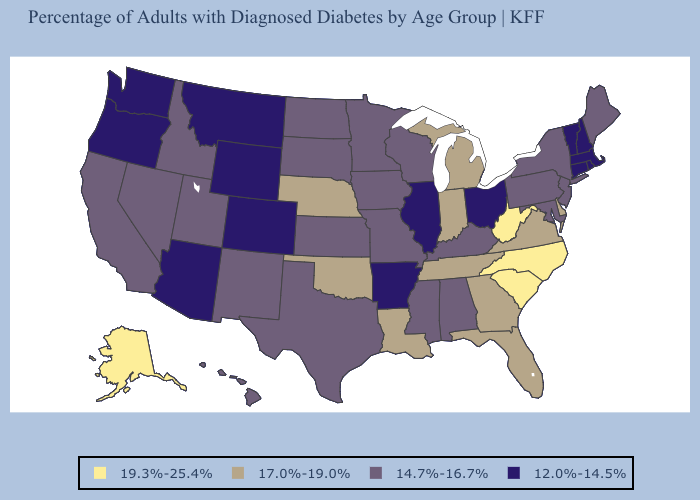Name the states that have a value in the range 17.0%-19.0%?
Quick response, please. Delaware, Florida, Georgia, Indiana, Louisiana, Michigan, Nebraska, Oklahoma, Tennessee, Virginia. What is the lowest value in the Northeast?
Keep it brief. 12.0%-14.5%. What is the value of Delaware?
Quick response, please. 17.0%-19.0%. Name the states that have a value in the range 19.3%-25.4%?
Short answer required. Alaska, North Carolina, South Carolina, West Virginia. What is the lowest value in states that border Wisconsin?
Quick response, please. 12.0%-14.5%. What is the value of North Dakota?
Keep it brief. 14.7%-16.7%. Which states hav the highest value in the South?
Short answer required. North Carolina, South Carolina, West Virginia. Among the states that border California , which have the lowest value?
Answer briefly. Arizona, Oregon. Name the states that have a value in the range 12.0%-14.5%?
Concise answer only. Arizona, Arkansas, Colorado, Connecticut, Illinois, Massachusetts, Montana, New Hampshire, Ohio, Oregon, Rhode Island, Vermont, Washington, Wyoming. Which states have the lowest value in the Northeast?
Concise answer only. Connecticut, Massachusetts, New Hampshire, Rhode Island, Vermont. Among the states that border North Carolina , does Tennessee have the highest value?
Concise answer only. No. Among the states that border Louisiana , which have the highest value?
Answer briefly. Mississippi, Texas. Which states hav the highest value in the MidWest?
Give a very brief answer. Indiana, Michigan, Nebraska. Does Arkansas have the lowest value in the USA?
Write a very short answer. Yes. Among the states that border Connecticut , does Massachusetts have the lowest value?
Give a very brief answer. Yes. 